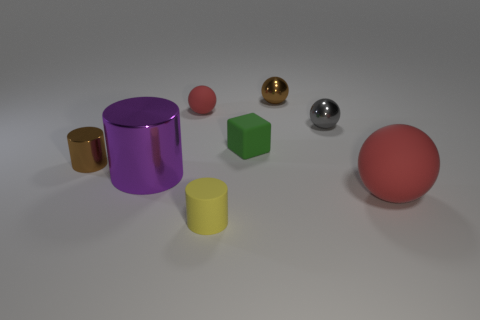What is the size of the other thing that is the same color as the large matte object?
Provide a short and direct response. Small. Is the shape of the gray thing the same as the red matte thing on the left side of the big red thing?
Your response must be concise. Yes. There is a rubber object that is in front of the small red object and behind the big metallic object; what is its shape?
Make the answer very short. Cube. Is the number of metal balls that are in front of the block the same as the number of tiny cylinders behind the tiny brown cylinder?
Offer a very short reply. Yes. There is a large thing that is left of the small gray thing; does it have the same shape as the tiny yellow rubber thing?
Offer a terse response. Yes. What number of yellow things are large things or tiny metallic objects?
Offer a terse response. 0. There is a small brown object that is the same shape as the small gray thing; what is its material?
Offer a very short reply. Metal. What is the shape of the big thing right of the brown sphere?
Make the answer very short. Sphere. Are there any other tiny green blocks that have the same material as the green block?
Keep it short and to the point. No. Do the green block and the yellow cylinder have the same size?
Your answer should be very brief. Yes. 